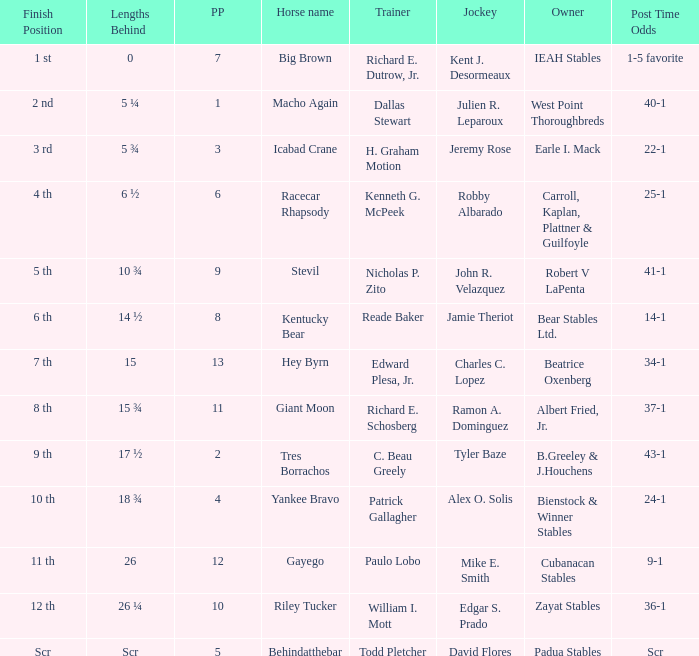Who was the jockey that had post time odds of 34-1? Charles C. Lopez. 